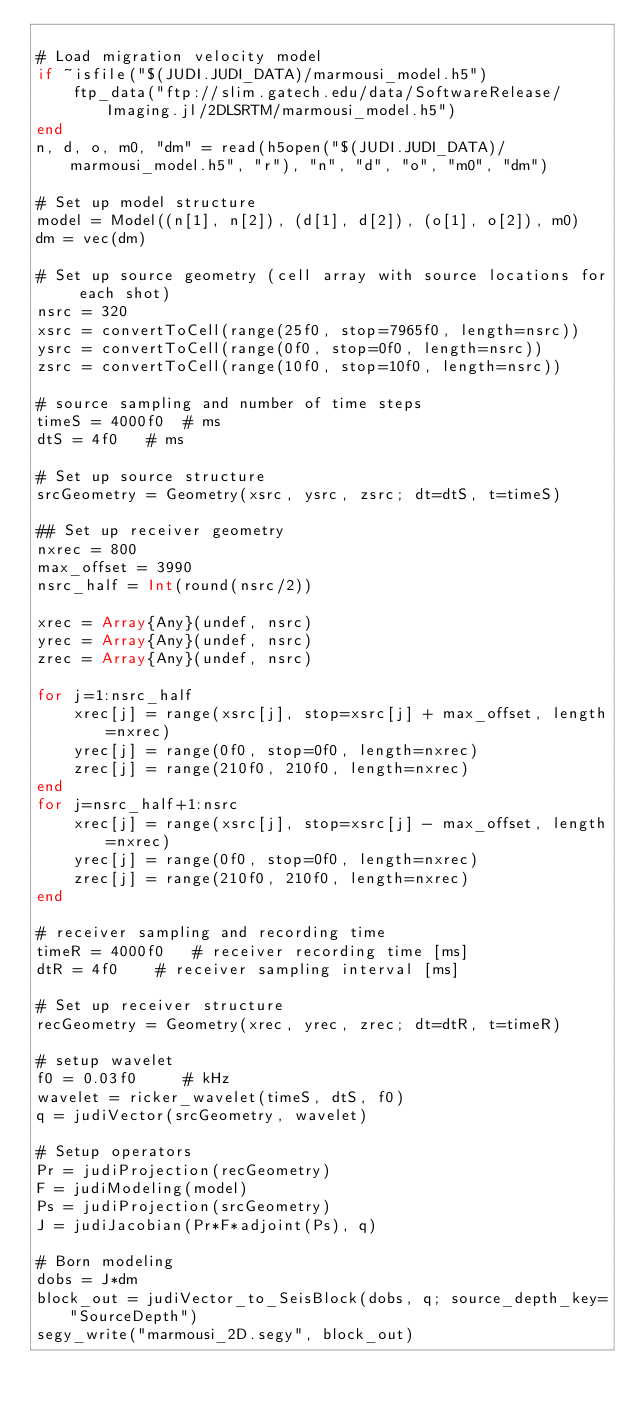<code> <loc_0><loc_0><loc_500><loc_500><_Julia_>
# Load migration velocity model
if ~isfile("$(JUDI.JUDI_DATA)/marmousi_model.h5")
    ftp_data("ftp://slim.gatech.edu/data/SoftwareRelease/Imaging.jl/2DLSRTM/marmousi_model.h5")
end
n, d, o, m0, "dm" = read(h5open("$(JUDI.JUDI_DATA)/marmousi_model.h5", "r"), "n", "d", "o", "m0", "dm")

# Set up model structure
model = Model((n[1], n[2]), (d[1], d[2]), (o[1], o[2]), m0)
dm = vec(dm)

# Set up source geometry (cell array with source locations for each shot)
nsrc = 320
xsrc = convertToCell(range(25f0, stop=7965f0, length=nsrc))
ysrc = convertToCell(range(0f0, stop=0f0, length=nsrc))
zsrc = convertToCell(range(10f0, stop=10f0, length=nsrc))

# source sampling and number of time steps
timeS = 4000f0  # ms
dtS = 4f0   # ms

# Set up source structure
srcGeometry = Geometry(xsrc, ysrc, zsrc; dt=dtS, t=timeS)

## Set up receiver geometry
nxrec = 800
max_offset = 3990
nsrc_half = Int(round(nsrc/2))

xrec = Array{Any}(undef, nsrc)
yrec = Array{Any}(undef, nsrc)
zrec = Array{Any}(undef, nsrc)

for j=1:nsrc_half
    xrec[j] = range(xsrc[j], stop=xsrc[j] + max_offset, length=nxrec)
    yrec[j] = range(0f0, stop=0f0, length=nxrec)
    zrec[j] = range(210f0, 210f0, length=nxrec)
end
for j=nsrc_half+1:nsrc
    xrec[j] = range(xsrc[j], stop=xsrc[j] - max_offset, length=nxrec)
    yrec[j] = range(0f0, stop=0f0, length=nxrec)
    zrec[j] = range(210f0, 210f0, length=nxrec)
end

# receiver sampling and recording time
timeR = 4000f0   # receiver recording time [ms]
dtR = 4f0    # receiver sampling interval [ms]

# Set up receiver structure
recGeometry = Geometry(xrec, yrec, zrec; dt=dtR, t=timeR)

# setup wavelet
f0 = 0.03f0     # kHz
wavelet = ricker_wavelet(timeS, dtS, f0)
q = judiVector(srcGeometry, wavelet)

# Setup operators
Pr = judiProjection(recGeometry)
F = judiModeling(model)
Ps = judiProjection(srcGeometry)
J = judiJacobian(Pr*F*adjoint(Ps), q)

# Born modeling
dobs = J*dm
block_out = judiVector_to_SeisBlock(dobs, q; source_depth_key="SourceDepth")
segy_write("marmousi_2D.segy", block_out)
</code> 